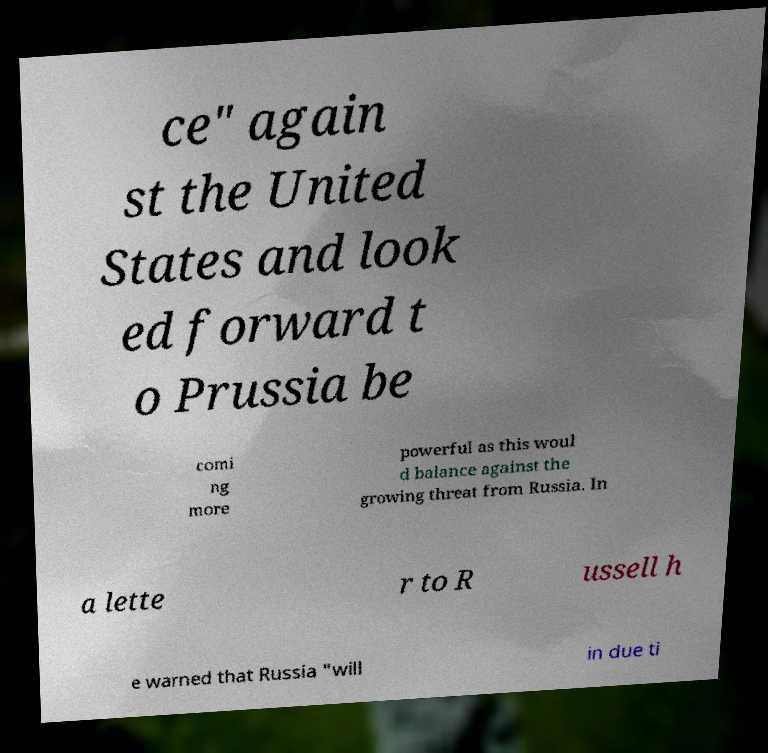There's text embedded in this image that I need extracted. Can you transcribe it verbatim? ce" again st the United States and look ed forward t o Prussia be comi ng more powerful as this woul d balance against the growing threat from Russia. In a lette r to R ussell h e warned that Russia "will in due ti 